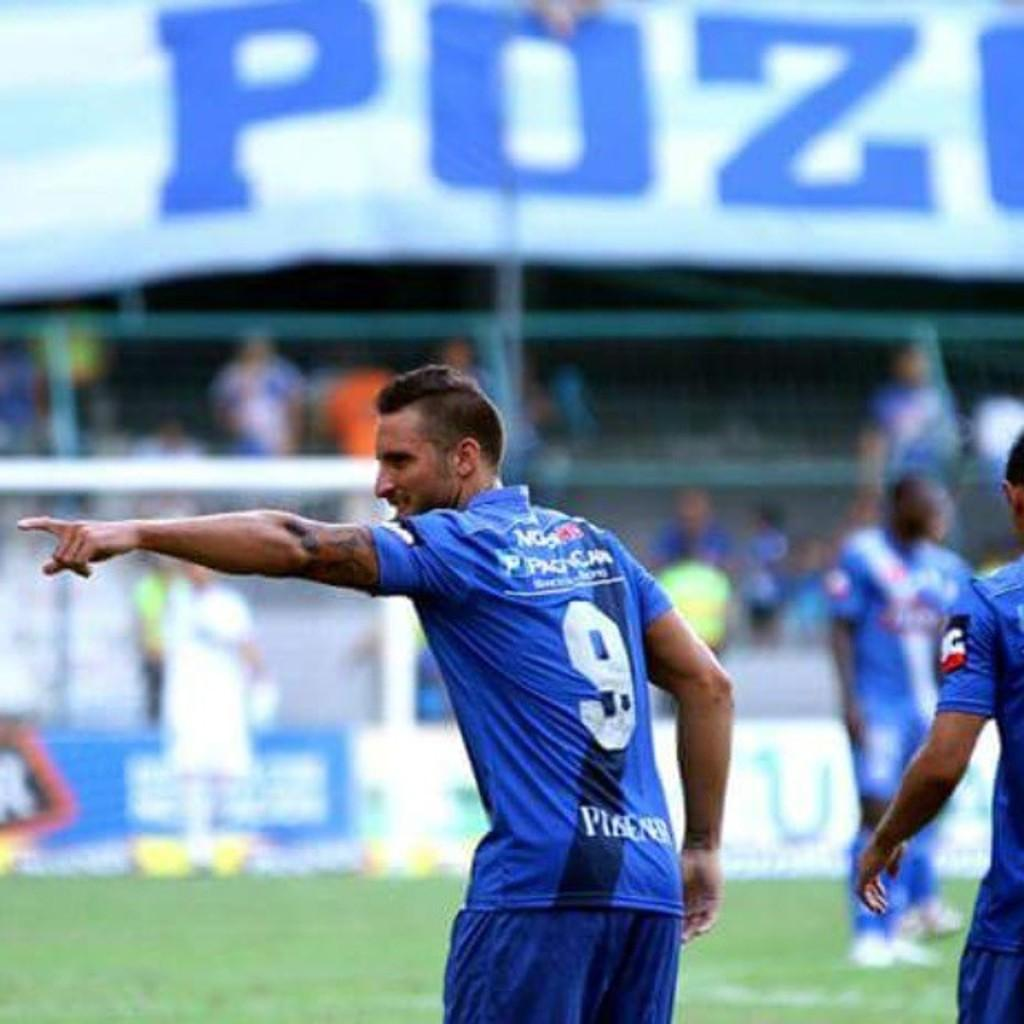<image>
Describe the image concisely. Man playing soccer pointing left, he is #9 on the field. 